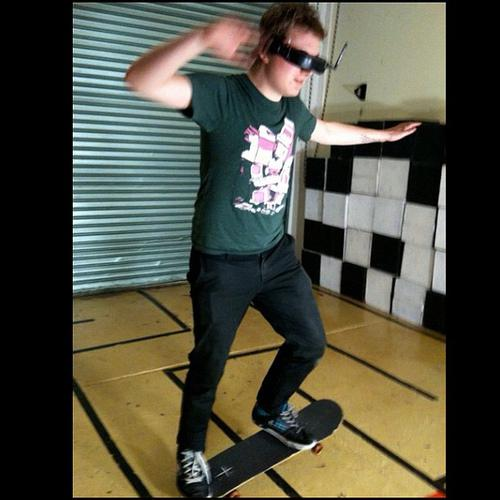Question: where is the boy standing?
Choices:
A. On the skateboard.
B. On the sidewalk.
C. In the street.
D. By the house.
Answer with the letter. Answer: A Question: who is on the skateboard?
Choices:
A. The girl.
B. The child.
C. The boy.
D. The man.
Answer with the letter. Answer: C Question: what is under the boy?
Choices:
A. Skates.
B. Skiis.
C. Snowboard.
D. The skateboard.
Answer with the letter. Answer: D 